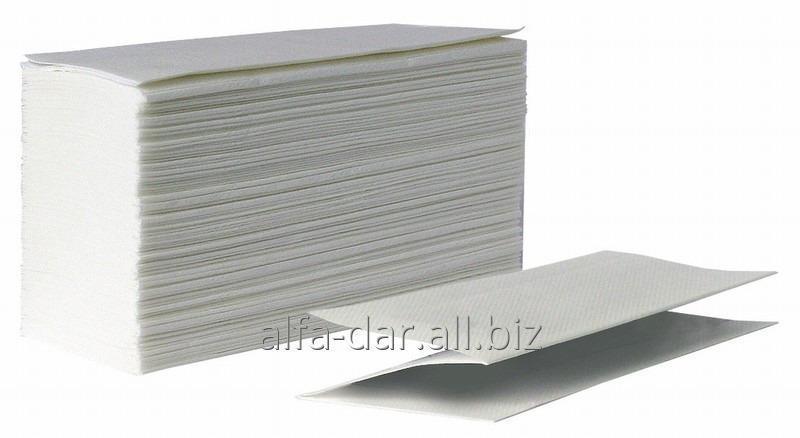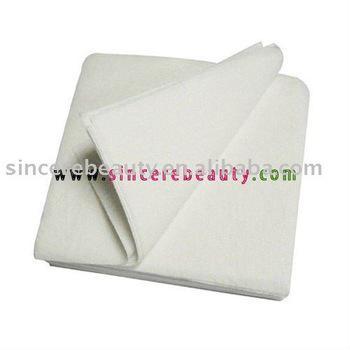The first image is the image on the left, the second image is the image on the right. Considering the images on both sides, is "The image on the left shows a human hand grabbing the edge of a paper towel." valid? Answer yes or no. No. The first image is the image on the left, the second image is the image on the right. For the images shown, is this caption "A human hand is partially visible in the right image." true? Answer yes or no. No. 